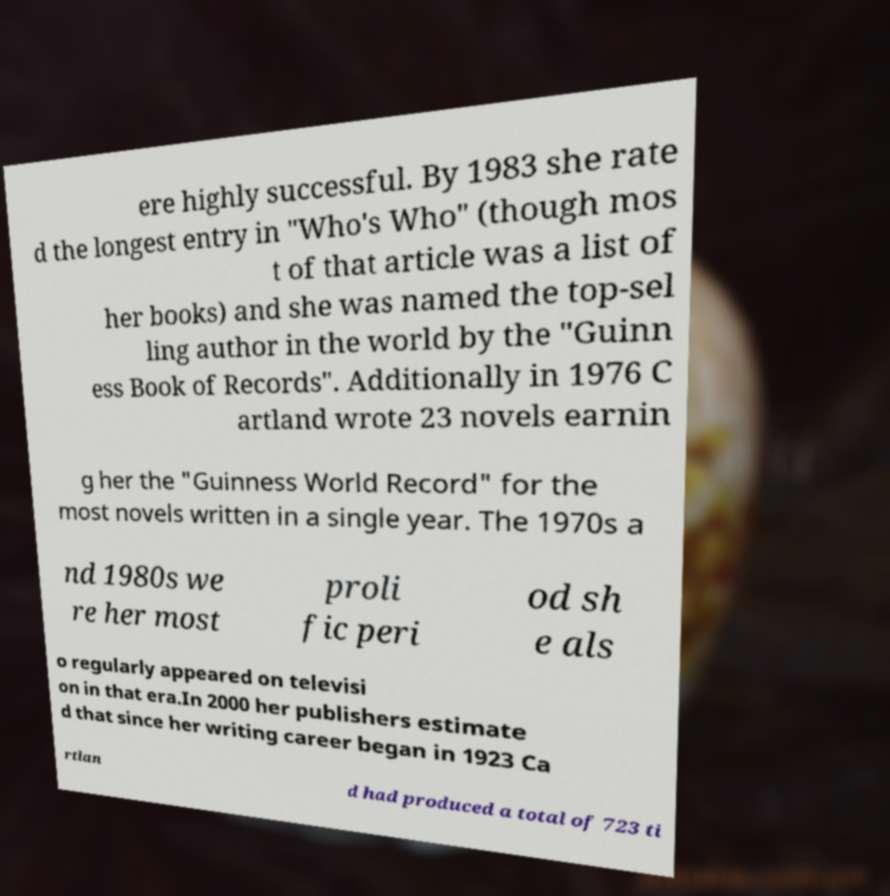Could you extract and type out the text from this image? ere highly successful. By 1983 she rate d the longest entry in "Who's Who" (though mos t of that article was a list of her books) and she was named the top-sel ling author in the world by the "Guinn ess Book of Records". Additionally in 1976 C artland wrote 23 novels earnin g her the "Guinness World Record" for the most novels written in a single year. The 1970s a nd 1980s we re her most proli fic peri od sh e als o regularly appeared on televisi on in that era.In 2000 her publishers estimate d that since her writing career began in 1923 Ca rtlan d had produced a total of 723 ti 